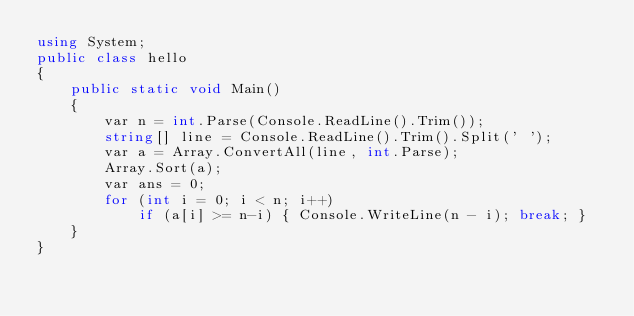<code> <loc_0><loc_0><loc_500><loc_500><_C#_>using System;
public class hello
{
    public static void Main()
    {
        var n = int.Parse(Console.ReadLine().Trim());
        string[] line = Console.ReadLine().Trim().Split(' ');
        var a = Array.ConvertAll(line, int.Parse);
        Array.Sort(a);
        var ans = 0;
        for (int i = 0; i < n; i++)
            if (a[i] >= n-i) { Console.WriteLine(n - i); break; }
    }
}</code> 